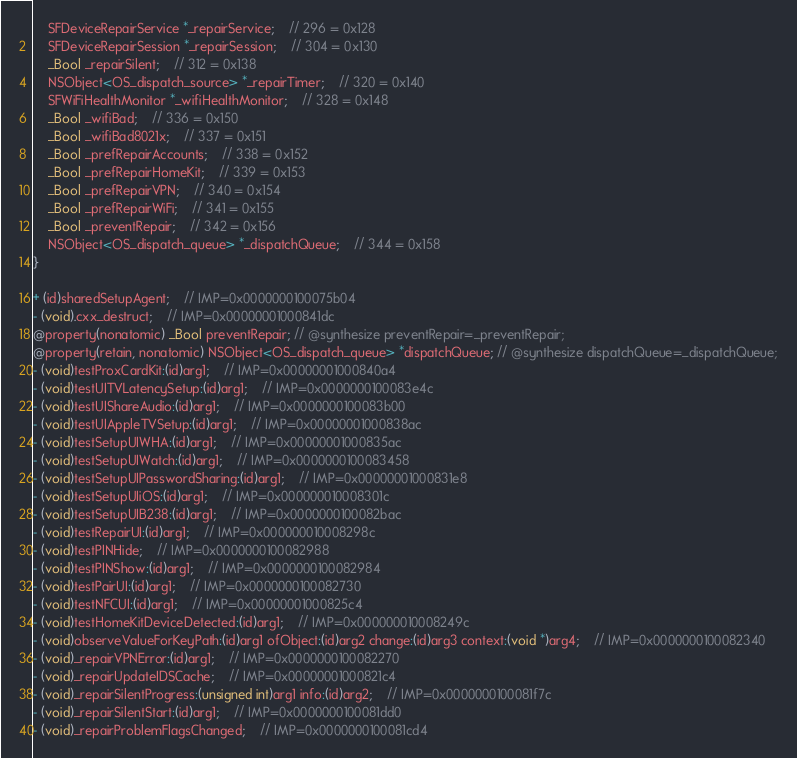Convert code to text. <code><loc_0><loc_0><loc_500><loc_500><_C_>    SFDeviceRepairService *_repairService;	// 296 = 0x128
    SFDeviceRepairSession *_repairSession;	// 304 = 0x130
    _Bool _repairSilent;	// 312 = 0x138
    NSObject<OS_dispatch_source> *_repairTimer;	// 320 = 0x140
    SFWiFiHealthMonitor *_wifiHealthMonitor;	// 328 = 0x148
    _Bool _wifiBad;	// 336 = 0x150
    _Bool _wifiBad8021x;	// 337 = 0x151
    _Bool _prefRepairAccounts;	// 338 = 0x152
    _Bool _prefRepairHomeKit;	// 339 = 0x153
    _Bool _prefRepairVPN;	// 340 = 0x154
    _Bool _prefRepairWiFi;	// 341 = 0x155
    _Bool _preventRepair;	// 342 = 0x156
    NSObject<OS_dispatch_queue> *_dispatchQueue;	// 344 = 0x158
}

+ (id)sharedSetupAgent;	// IMP=0x0000000100075b04
- (void).cxx_destruct;	// IMP=0x00000001000841dc
@property(nonatomic) _Bool preventRepair; // @synthesize preventRepair=_preventRepair;
@property(retain, nonatomic) NSObject<OS_dispatch_queue> *dispatchQueue; // @synthesize dispatchQueue=_dispatchQueue;
- (void)testProxCardKit:(id)arg1;	// IMP=0x00000001000840a4
- (void)testUITVLatencySetup:(id)arg1;	// IMP=0x0000000100083e4c
- (void)testUIShareAudio:(id)arg1;	// IMP=0x0000000100083b00
- (void)testUIAppleTVSetup:(id)arg1;	// IMP=0x00000001000838ac
- (void)testSetupUIWHA:(id)arg1;	// IMP=0x00000001000835ac
- (void)testSetupUIWatch:(id)arg1;	// IMP=0x0000000100083458
- (void)testSetupUIPasswordSharing:(id)arg1;	// IMP=0x00000001000831e8
- (void)testSetupUIiOS:(id)arg1;	// IMP=0x000000010008301c
- (void)testSetupUIB238:(id)arg1;	// IMP=0x0000000100082bac
- (void)testRepairUI:(id)arg1;	// IMP=0x000000010008298c
- (void)testPINHide;	// IMP=0x0000000100082988
- (void)testPINShow:(id)arg1;	// IMP=0x0000000100082984
- (void)testPairUI:(id)arg1;	// IMP=0x0000000100082730
- (void)testNFCUI:(id)arg1;	// IMP=0x00000001000825c4
- (void)testHomeKitDeviceDetected:(id)arg1;	// IMP=0x000000010008249c
- (void)observeValueForKeyPath:(id)arg1 ofObject:(id)arg2 change:(id)arg3 context:(void *)arg4;	// IMP=0x0000000100082340
- (void)_repairVPNError:(id)arg1;	// IMP=0x0000000100082270
- (void)_repairUpdateIDSCache;	// IMP=0x00000001000821c4
- (void)_repairSilentProgress:(unsigned int)arg1 info:(id)arg2;	// IMP=0x0000000100081f7c
- (void)_repairSilentStart:(id)arg1;	// IMP=0x0000000100081dd0
- (void)_repairProblemFlagsChanged;	// IMP=0x0000000100081cd4</code> 